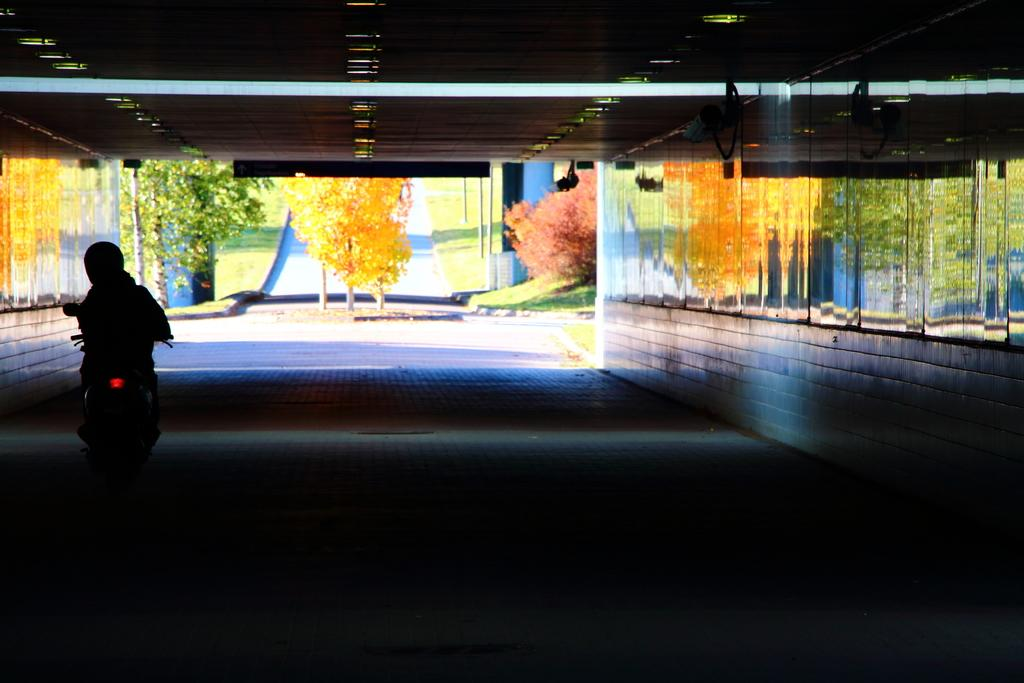What is the main subject of the image? There is a person riding a motorcycle in the image. Where is the motorcycle located? The motorcycle is on the road. What can be seen on the wall beside the person? There are arts on the wall beside the person. What type of natural elements are visible in the image? Trees are visible in the image. What are the vertical structures present in the image? Poles are present in the image. How many babies are sitting on the motorcycle in the image? There are no babies present in the image; it features a person riding a motorcycle. What type of cap is the person wearing in the image? There is no cap visible in the image; the person is wearing a helmet. 